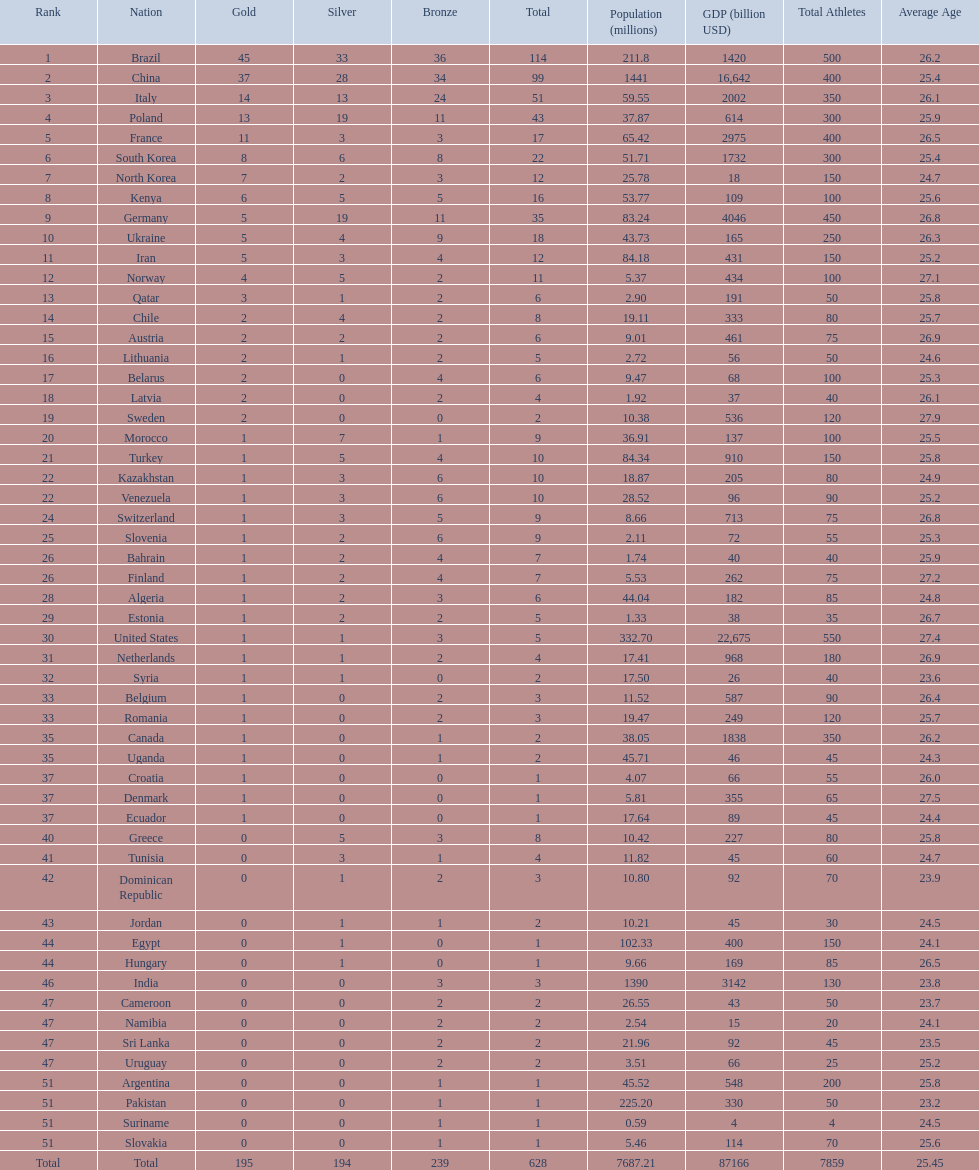What is the total number of medals between south korea, north korea, sweden, and brazil? 150. 